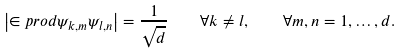Convert formula to latex. <formula><loc_0><loc_0><loc_500><loc_500>\left | \in p r o d { \psi _ { k , m } } { \psi _ { l , n } } \right | = \frac { 1 } { \sqrt { d } } \quad \forall k \neq l , \quad \forall m , n = 1 , \dots , d .</formula> 